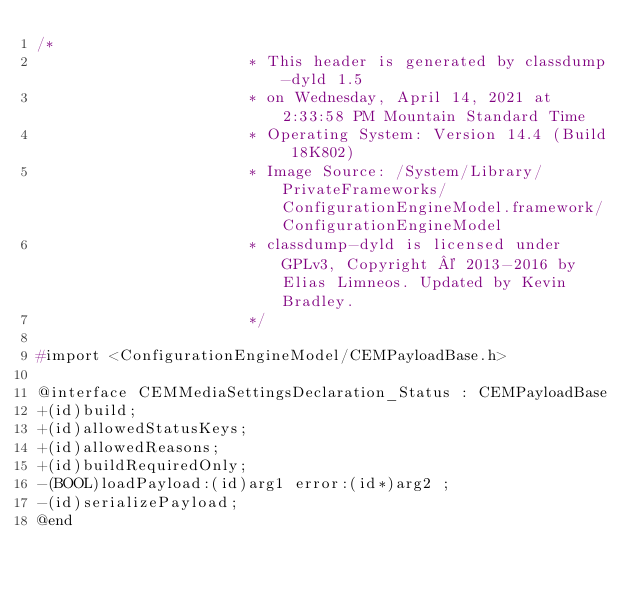Convert code to text. <code><loc_0><loc_0><loc_500><loc_500><_C_>/*
                       * This header is generated by classdump-dyld 1.5
                       * on Wednesday, April 14, 2021 at 2:33:58 PM Mountain Standard Time
                       * Operating System: Version 14.4 (Build 18K802)
                       * Image Source: /System/Library/PrivateFrameworks/ConfigurationEngineModel.framework/ConfigurationEngineModel
                       * classdump-dyld is licensed under GPLv3, Copyright © 2013-2016 by Elias Limneos. Updated by Kevin Bradley.
                       */

#import <ConfigurationEngineModel/CEMPayloadBase.h>

@interface CEMMediaSettingsDeclaration_Status : CEMPayloadBase
+(id)build;
+(id)allowedStatusKeys;
+(id)allowedReasons;
+(id)buildRequiredOnly;
-(BOOL)loadPayload:(id)arg1 error:(id*)arg2 ;
-(id)serializePayload;
@end

</code> 